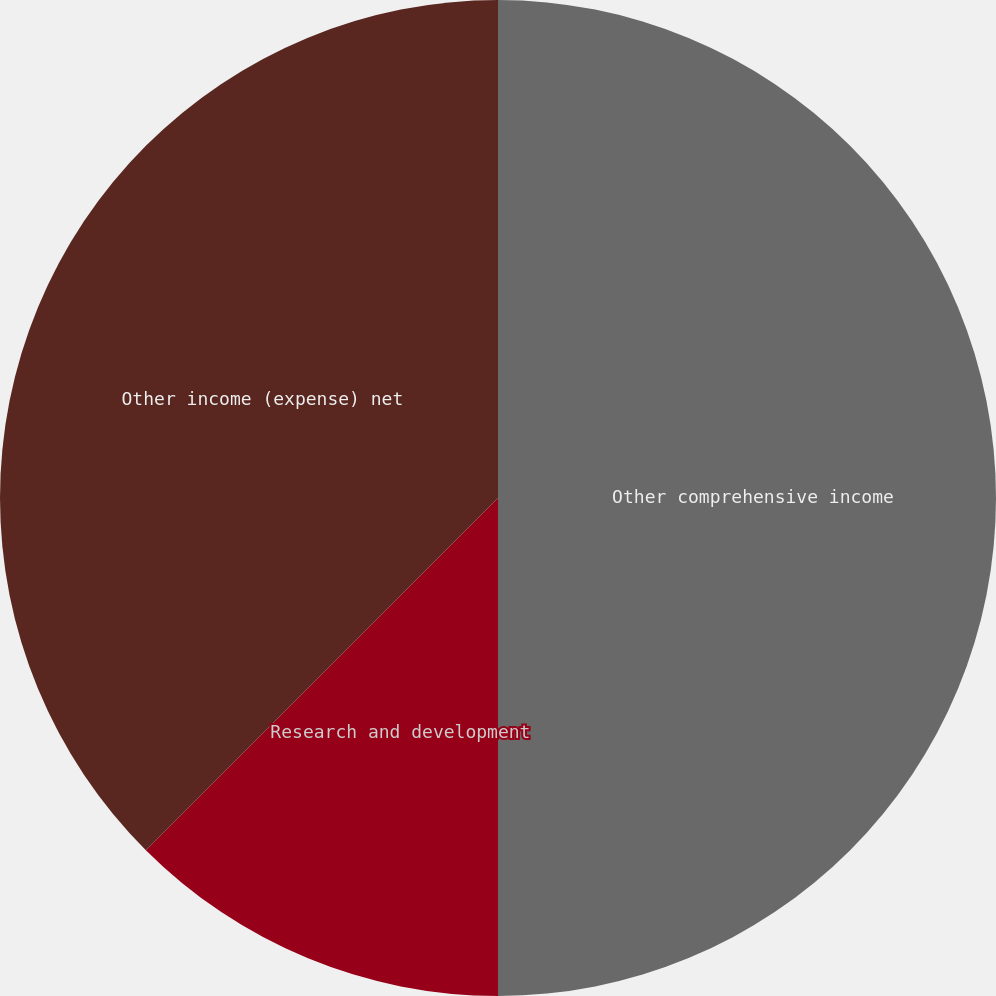<chart> <loc_0><loc_0><loc_500><loc_500><pie_chart><fcel>Other comprehensive income<fcel>Research and development<fcel>Other income (expense) net<nl><fcel>50.0%<fcel>12.5%<fcel>37.5%<nl></chart> 